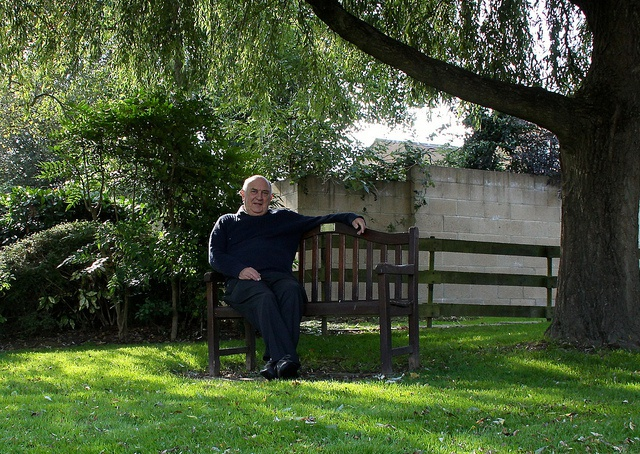Describe the objects in this image and their specific colors. I can see bench in lightgreen, black, gray, and darkgreen tones and people in lightgreen, black, gray, and lightgray tones in this image. 